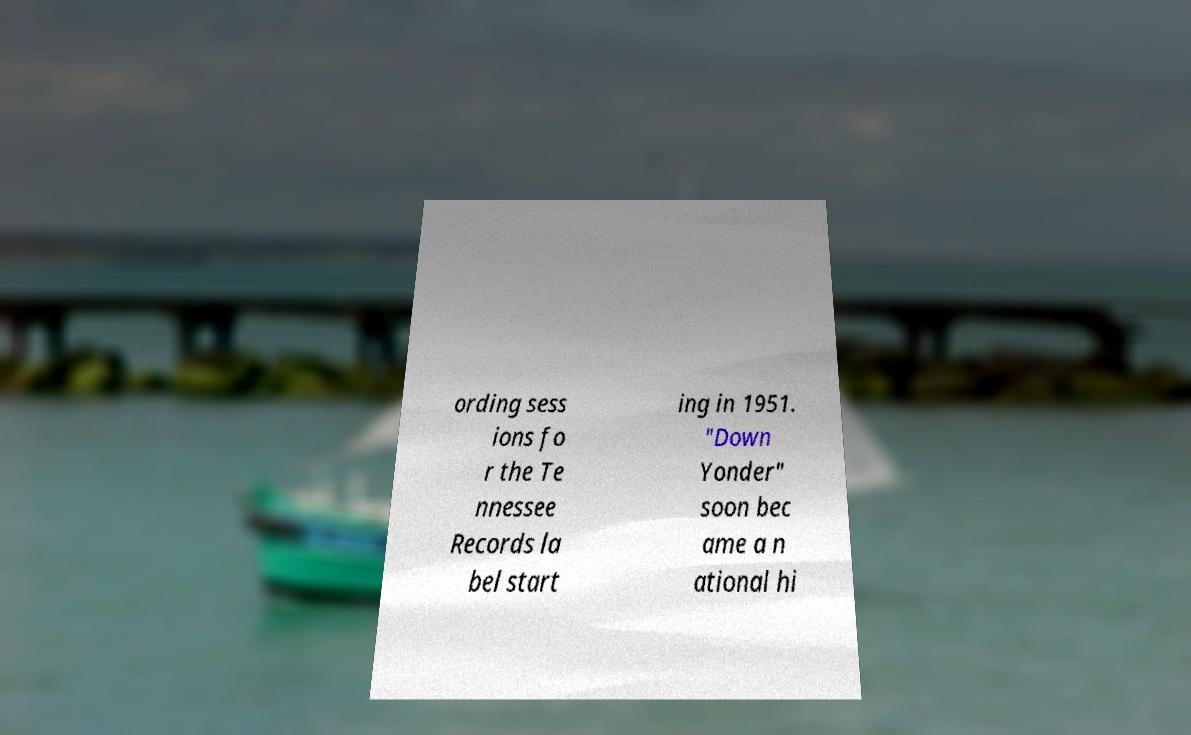I need the written content from this picture converted into text. Can you do that? ording sess ions fo r the Te nnessee Records la bel start ing in 1951. "Down Yonder" soon bec ame a n ational hi 